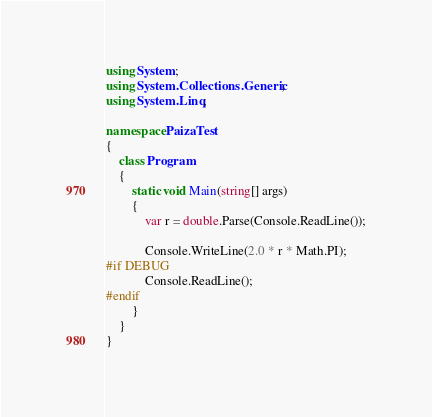<code> <loc_0><loc_0><loc_500><loc_500><_C#_>using System;
using System.Collections.Generic;
using System.Linq;
 
namespace PaizaTest
{
    class Program
    {
        static void Main(string[] args)
        {
            var r = double.Parse(Console.ReadLine());
 
            Console.WriteLine(2.0 * r * Math.PI);
#if DEBUG
            Console.ReadLine();
#endif
        }
    }
}</code> 